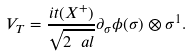Convert formula to latex. <formula><loc_0><loc_0><loc_500><loc_500>V _ { T } = \frac { i t ( X ^ { + } ) } { \sqrt { 2 \ a l } } \partial _ { \sigma } \phi ( \sigma ) \otimes \sigma ^ { 1 } .</formula> 